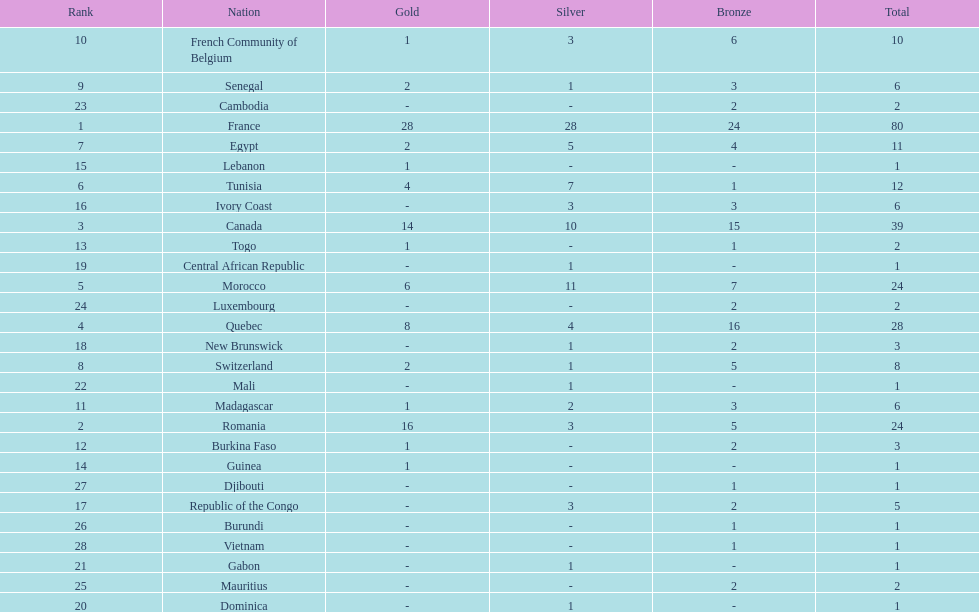How many counties have at least one silver medal? 18. 